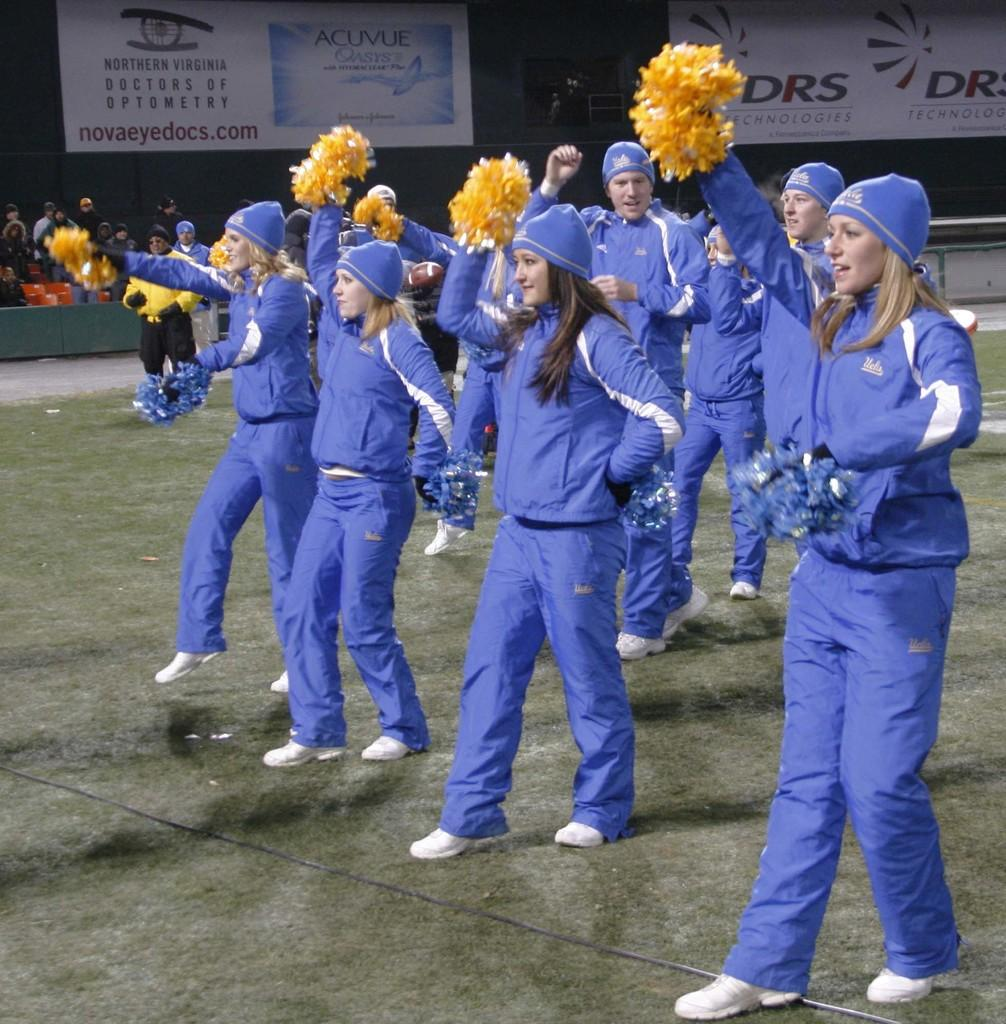What are the people in the image doing? The people in the image are dancing. What are the people holding in their hands? The people are holding objects in their hands. What can be seen hanging in the background or foreground of the image? There are banners visible in the image. How many people are present in the image? There are other people present in the image besides the group of people dancing. What is the purpose of the earthquake in the image? There is no earthquake present in the image; it is a scene of people dancing and holding objects. Is there a carpenter present in the image? There is no mention of a carpenter in the image, and no such profession is depicted. 